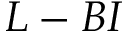Convert formula to latex. <formula><loc_0><loc_0><loc_500><loc_500>L - B I</formula> 